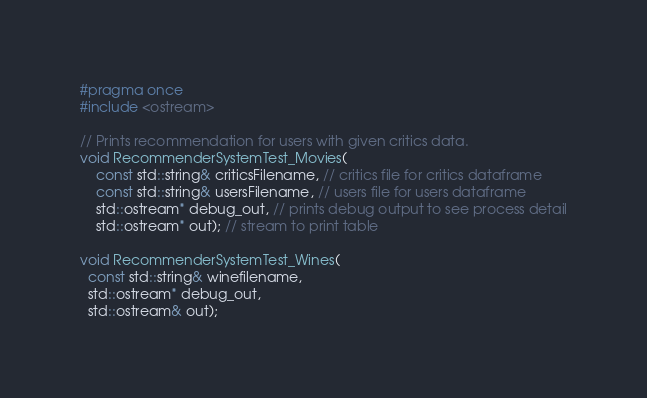<code> <loc_0><loc_0><loc_500><loc_500><_C_>#pragma once
#include <ostream>

// Prints recommendation for users with given critics data.
void RecommenderSystemTest_Movies(
	const std::string& criticsFilename, // critics file for critics dataframe
	const std::string& usersFilename, // users file for users dataframe
	std::ostream* debug_out, // prints debug output to see process detail
	std::ostream* out); // stream to print table

void RecommenderSystemTest_Wines(
  const std::string& winefilename,
  std::ostream* debug_out,
  std::ostream& out);
</code> 